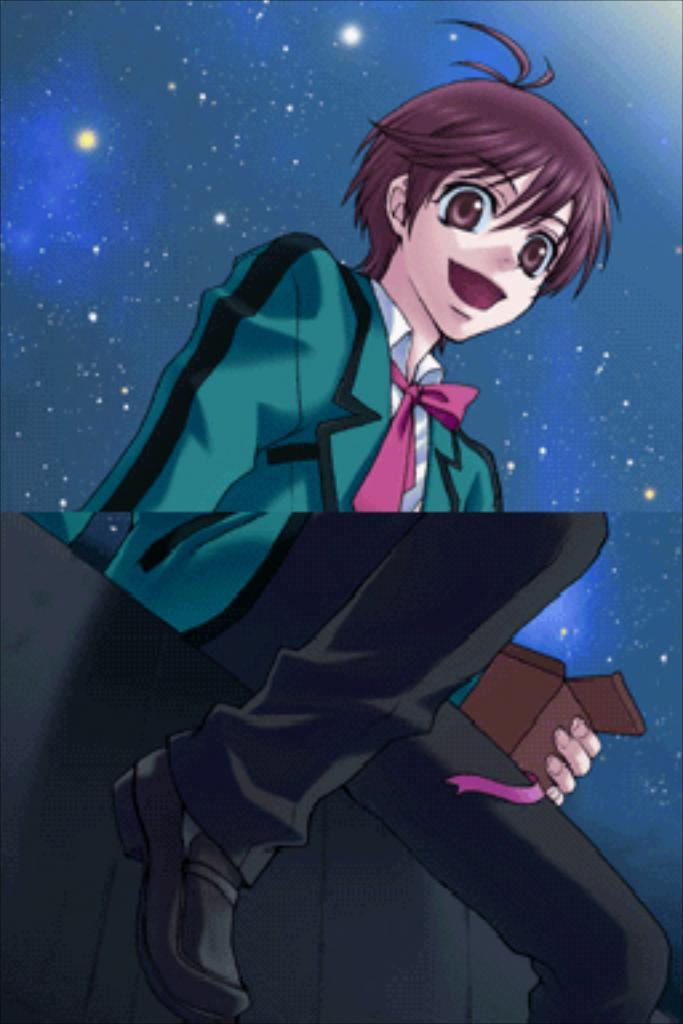What type of image is present in the picture? There is a cartoon image of a person in the picture. What is the person in the image doing? The person is sitting on something. What is the person holding in their hand? The person is holding an object in their hand. What can be seen in the background of the image? There are stars visible in the background of the image. What emotion is the person in the image expressing? The image does not show any specific emotion being expressed by the person. What shape is the object the person is holding? The provided facts do not mention the shape of the object the person is holding. 